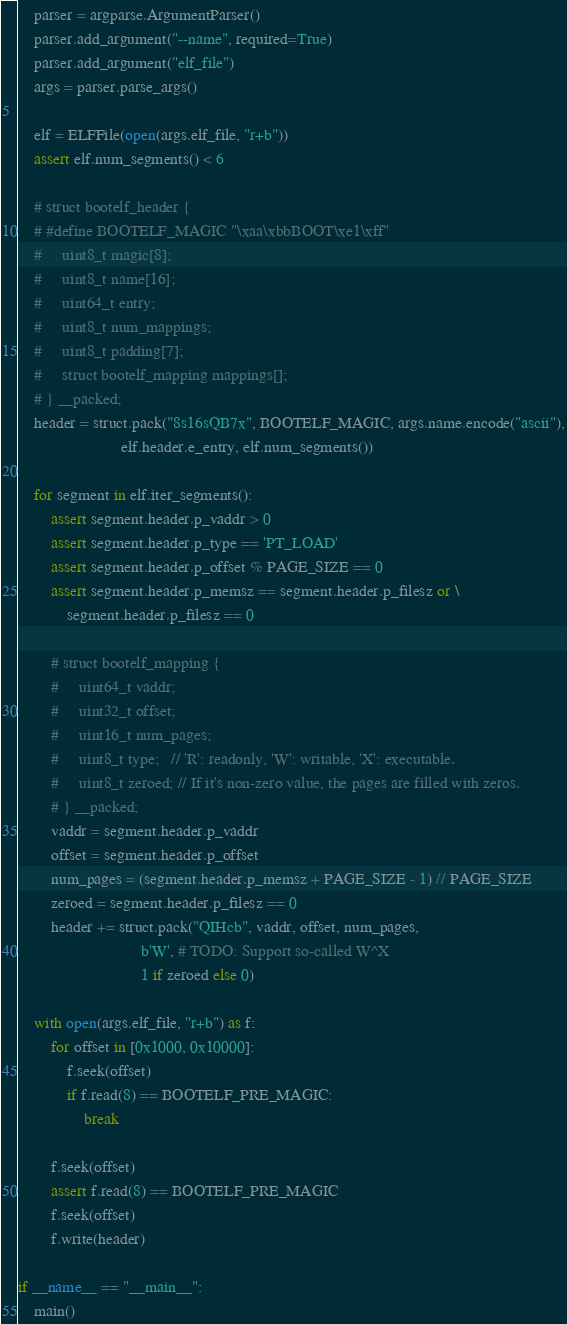<code> <loc_0><loc_0><loc_500><loc_500><_Python_>    parser = argparse.ArgumentParser()
    parser.add_argument("--name", required=True)
    parser.add_argument("elf_file")
    args = parser.parse_args()

    elf = ELFFile(open(args.elf_file, "r+b"))
    assert elf.num_segments() < 6

    # struct bootelf_header {
    # #define BOOTELF_MAGIC "\xaa\xbbBOOT\xe1\xff"
    #     uint8_t magic[8];
    #     uint8_t name[16];
    #     uint64_t entry;
    #     uint8_t num_mappings;
    #     uint8_t padding[7];
    #     struct bootelf_mapping mappings[];
    # } __packed;
    header = struct.pack("8s16sQB7x", BOOTELF_MAGIC, args.name.encode("ascii"),
                         elf.header.e_entry, elf.num_segments())

    for segment in elf.iter_segments():
        assert segment.header.p_vaddr > 0
        assert segment.header.p_type == 'PT_LOAD'
        assert segment.header.p_offset % PAGE_SIZE == 0
        assert segment.header.p_memsz == segment.header.p_filesz or \
            segment.header.p_filesz == 0

        # struct bootelf_mapping {
        #     uint64_t vaddr;
        #     uint32_t offset;
        #     uint16_t num_pages;
        #     uint8_t type;   // 'R': readonly, 'W': writable, 'X': executable.
        #     uint8_t zeroed; // If it's non-zero value, the pages are filled with zeros.
        # } __packed;
        vaddr = segment.header.p_vaddr
        offset = segment.header.p_offset
        num_pages = (segment.header.p_memsz + PAGE_SIZE - 1) // PAGE_SIZE
        zeroed = segment.header.p_filesz == 0
        header += struct.pack("QIHcb", vaddr, offset, num_pages,
                              b'W', # TODO: Support so-called W^X
                              1 if zeroed else 0)

    with open(args.elf_file, "r+b") as f:
        for offset in [0x1000, 0x10000]:
            f.seek(offset)
            if f.read(8) == BOOTELF_PRE_MAGIC:
                break

        f.seek(offset)
        assert f.read(8) == BOOTELF_PRE_MAGIC
        f.seek(offset)
        f.write(header)

if __name__ == "__main__":
    main()
</code> 